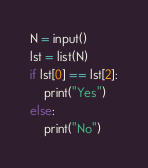<code> <loc_0><loc_0><loc_500><loc_500><_Python_>N = input()
lst = list(N)
if lst[0] == lst[2]:
    print("Yes")
else:
    print("No")
</code> 